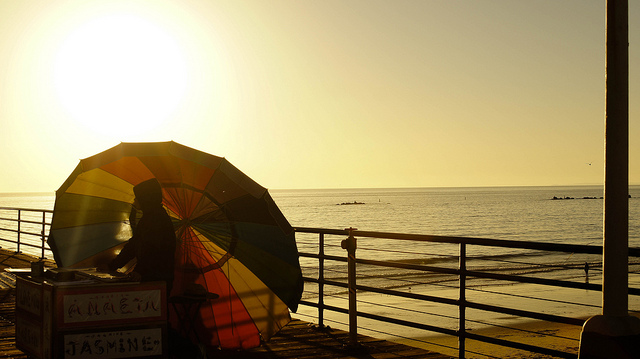What is the man holding? In the image, the item behind the man, partially obscured by his position and the angle, is a large, colorful umbrella. This umbrella, with vivid stripes, serves as a makeshift roof, likely for a beachside seller's cart, evidenced by the signage visible on the cart. 